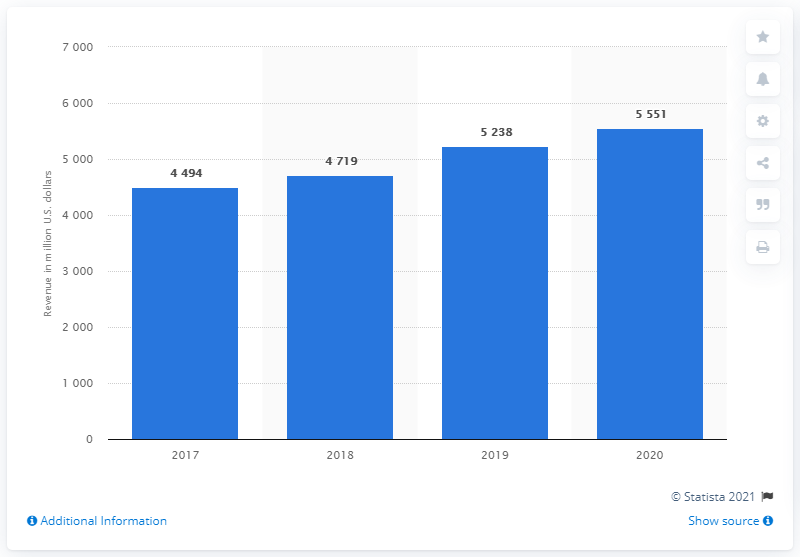Mention a couple of crucial points in this snapshot. Capri Holdings generated revenue of $55.51 billion in fiscal year 2020. 